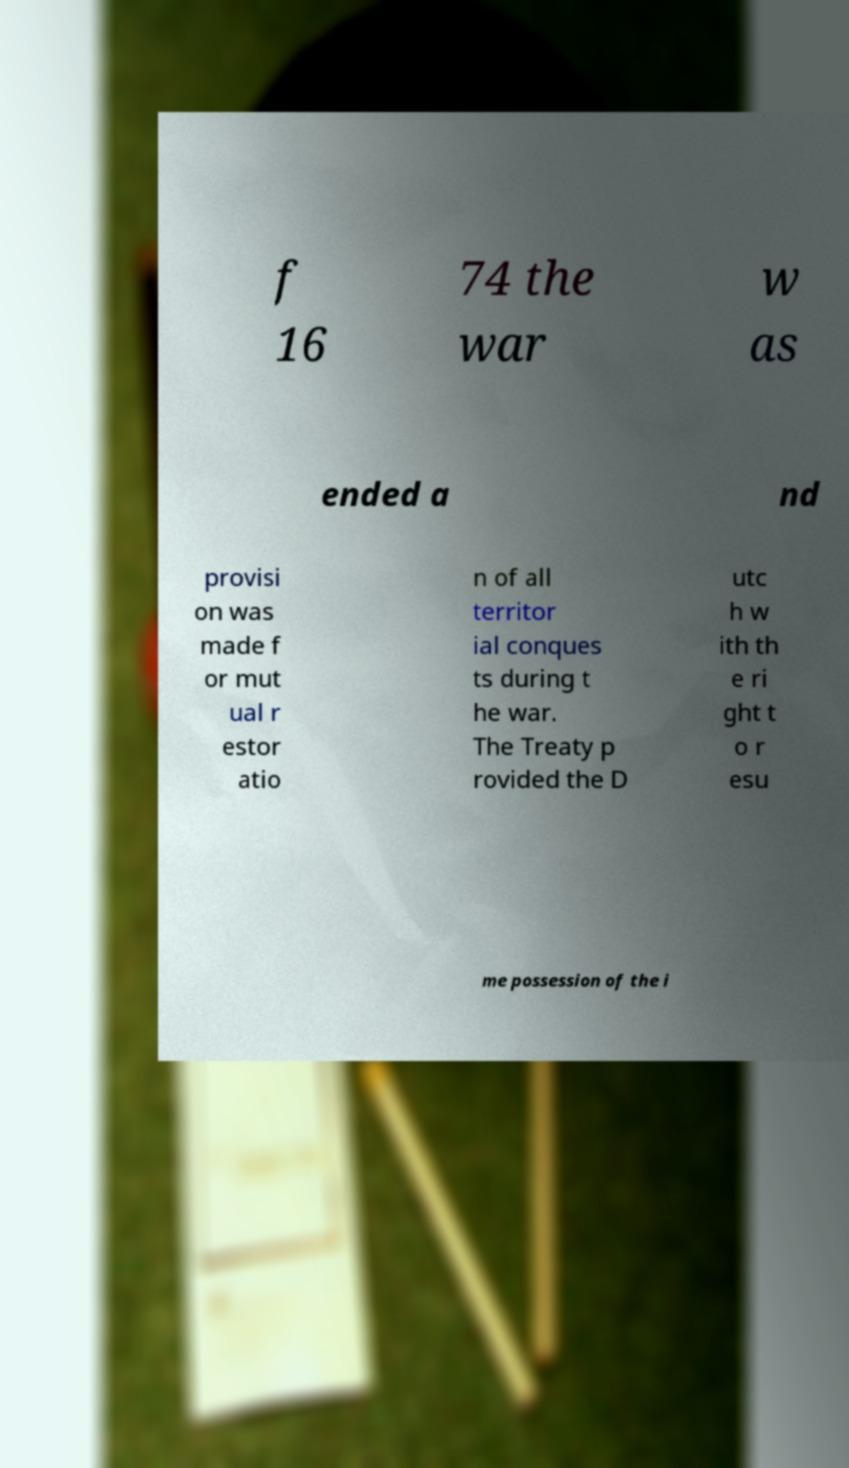I need the written content from this picture converted into text. Can you do that? f 16 74 the war w as ended a nd provisi on was made f or mut ual r estor atio n of all territor ial conques ts during t he war. The Treaty p rovided the D utc h w ith th e ri ght t o r esu me possession of the i 